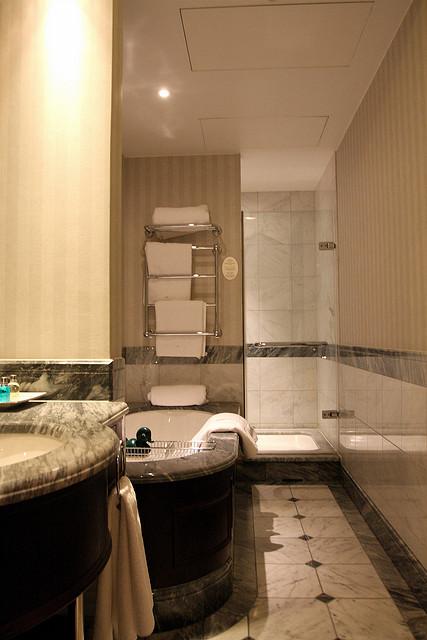How many floor tiles can be seen?
Keep it brief. 12. Is this a hotel?
Concise answer only. Yes. Is this a very nice bathroom?
Quick response, please. Yes. 